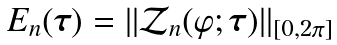Convert formula to latex. <formula><loc_0><loc_0><loc_500><loc_500>E _ { n } ( { \boldsymbol \tau } ) = | | { \mathcal { Z } } _ { n } ( \varphi ; { \boldsymbol \tau } ) | | _ { [ 0 , 2 \pi ] }</formula> 